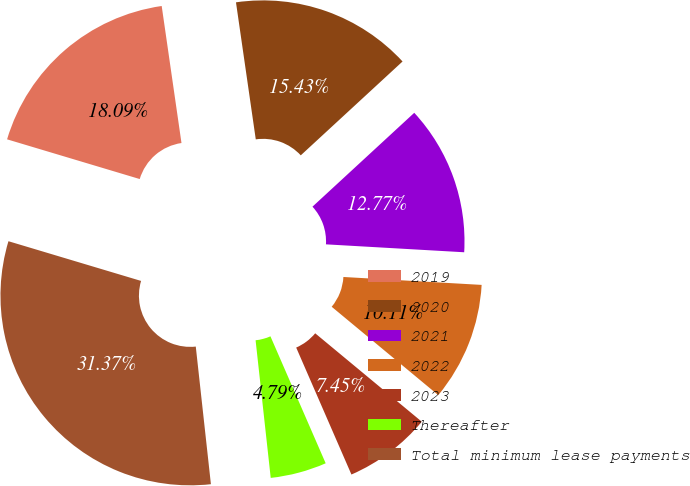Convert chart. <chart><loc_0><loc_0><loc_500><loc_500><pie_chart><fcel>2019<fcel>2020<fcel>2021<fcel>2022<fcel>2023<fcel>Thereafter<fcel>Total minimum lease payments<nl><fcel>18.09%<fcel>15.43%<fcel>12.77%<fcel>10.11%<fcel>7.45%<fcel>4.79%<fcel>31.38%<nl></chart> 